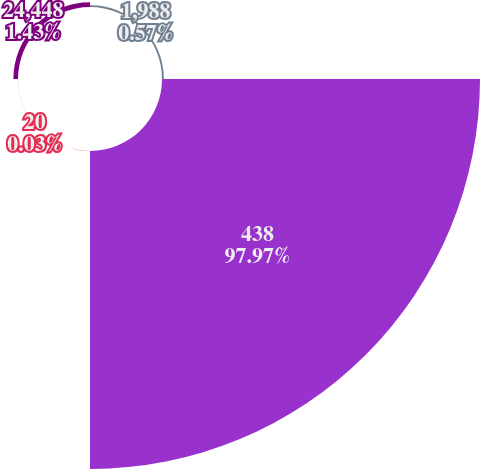<chart> <loc_0><loc_0><loc_500><loc_500><pie_chart><fcel>1,988<fcel>438<fcel>20<fcel>24,448<nl><fcel>0.57%<fcel>97.98%<fcel>0.03%<fcel>1.43%<nl></chart> 